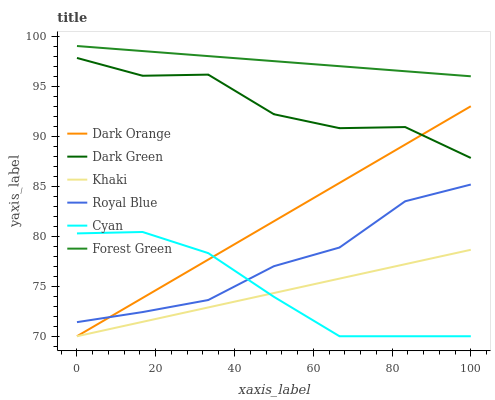Does Royal Blue have the minimum area under the curve?
Answer yes or no. No. Does Royal Blue have the maximum area under the curve?
Answer yes or no. No. Is Khaki the smoothest?
Answer yes or no. No. Is Khaki the roughest?
Answer yes or no. No. Does Royal Blue have the lowest value?
Answer yes or no. No. Does Royal Blue have the highest value?
Answer yes or no. No. Is Khaki less than Dark Green?
Answer yes or no. Yes. Is Forest Green greater than Cyan?
Answer yes or no. Yes. Does Khaki intersect Dark Green?
Answer yes or no. No. 